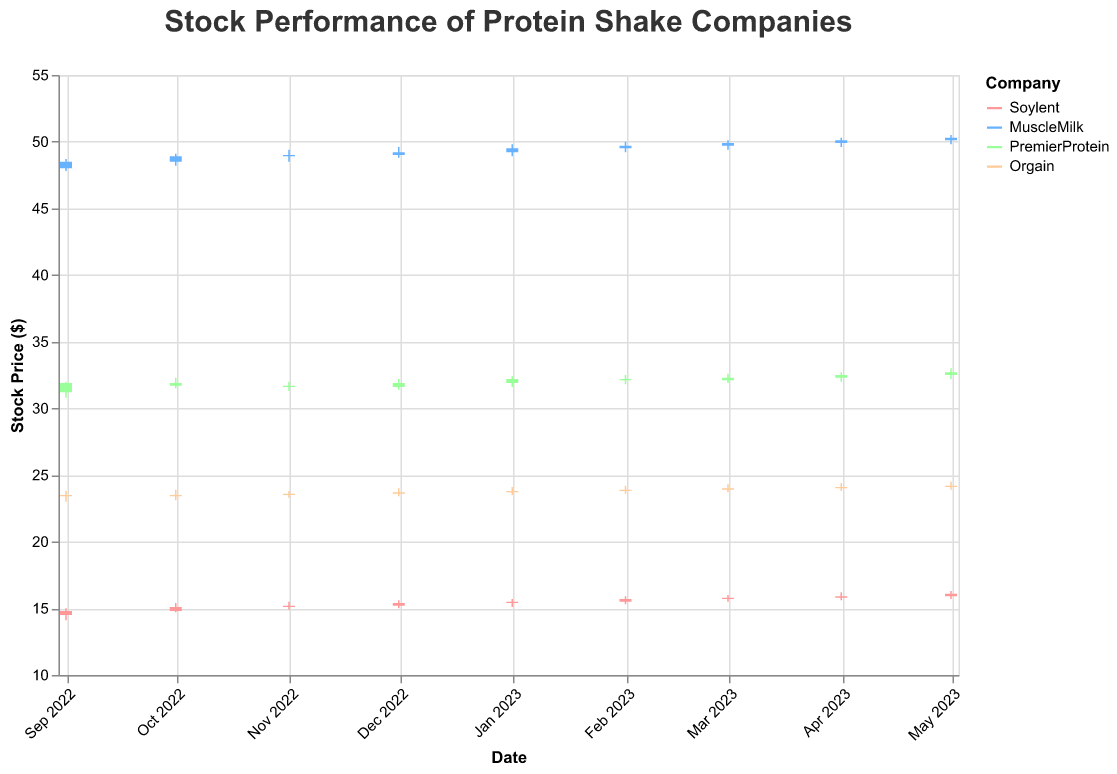What's the title of the figure? The title of the figure can be directly read from the top of the plot.
Answer: Stock Performance of Protein Shake Companies Which company had the highest closing stock price on May 1, 2023? By looking at the candlestick plots for May 1, 2023, we can see that MuscleMilk had the highest closing stock price.
Answer: MuscleMilk Among the four companies, which one had the lowest opening stock price in September 2022? Examining the candlestick data for September 2022, Orgain has the lowest opening stock price at $23.50.
Answer: Orgain What is the range of the highest and lowest prices for PremierProtein on October 1, 2022? We look at the high and low values for PremierProtein on October 1, 2022. The range is calculated as 32.30 - 31.50.
Answer: 0.80 Which company had consistent stock price increases from September 2022 to May 2023? Analyzing the closing prices over time, MuscleMilk shows consistent stock price increases in each month.
Answer: MuscleMilk By how much did Soylent's closing price change from September 2022 to May 2023? Looking at the closing prices for Soylent, the change is calculated as 16.10 - 14.80.
Answer: 1.30 Which company had the highest trading volume on the given dates and what was that volume? By inspecting the volume values, PremierProtein on September 1, 2022, had the highest trading volume at 4,470,000 shares.
Answer: PremierProtein, 4,470,000 What is the difference between the opening and closing prices for Orgain on April 1, 2023? For April 1, 2023, Orgain's opening price is 24.00, and the closing price is 24.10. The difference is calculated as 24.10 - 24.00.
Answer: 0.10 Which month did PremierProtein have its lowest closing stock price over the given period? By reviewing the closing prices month by month for PremierProtein, the lowest closing price is in November 2022 at $31.60.
Answer: November 2022 